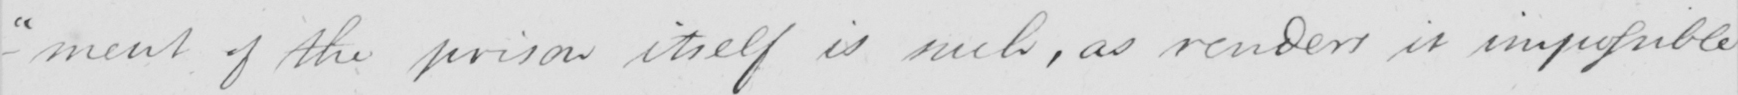What does this handwritten line say? -ment of the prison itself is such , as renders it impossible 